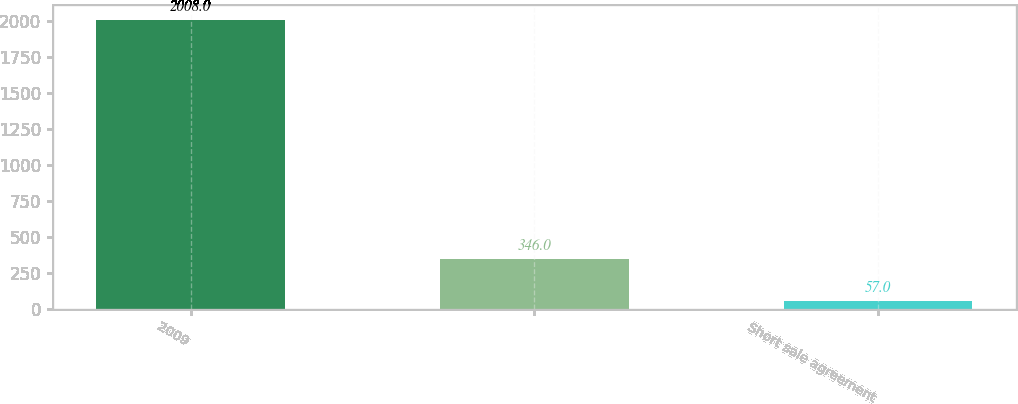Convert chart to OTSL. <chart><loc_0><loc_0><loc_500><loc_500><bar_chart><fcel>2009<fcel>Unnamed: 1<fcel>Short sale agreement<nl><fcel>2008<fcel>346<fcel>57<nl></chart> 